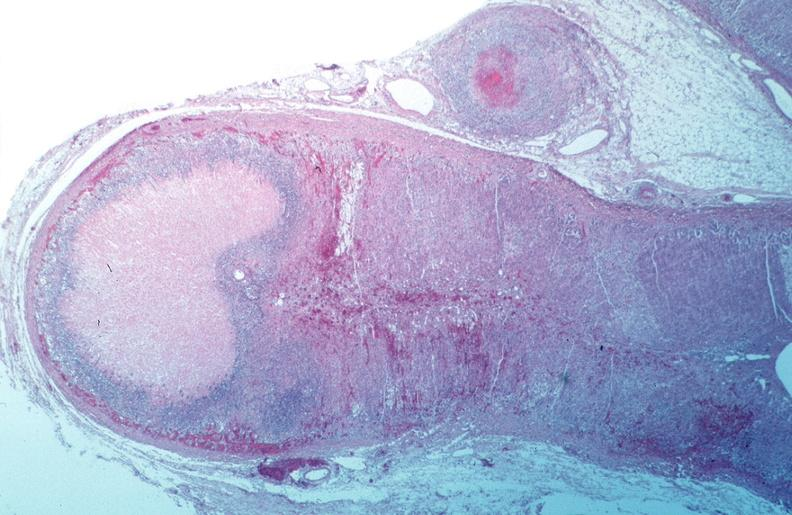s this image present?
Answer the question using a single word or phrase. No 